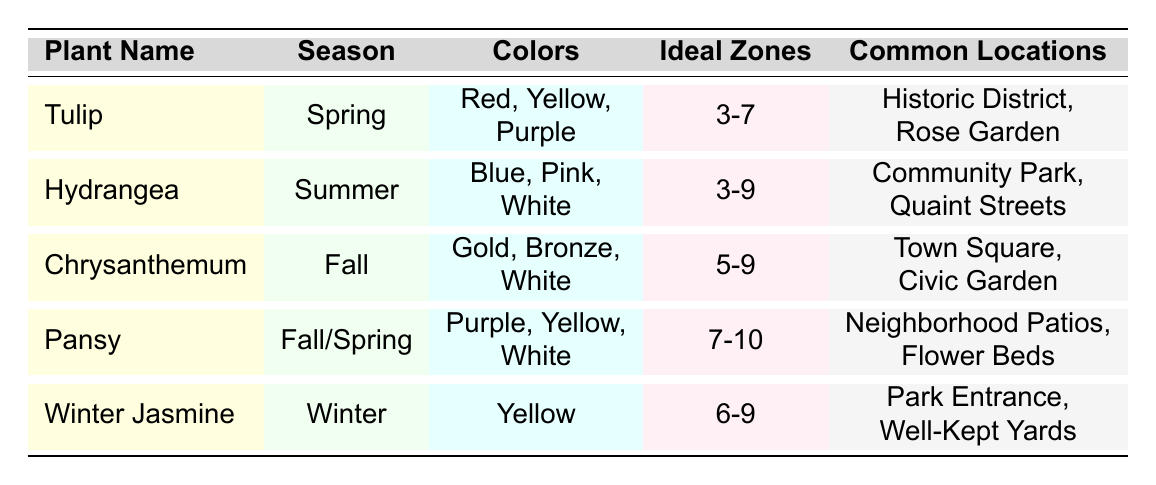What is the common location for Tulips? The table lists the common locations for Tulips as "Historic District" and "Rose Garden."
Answer: Historic District, Rose Garden Which season does the Hydrangea bloom? According to the table, the Hydrangea blooms in the Summer season.
Answer: Summer How many colors does the Chrysanthemum come in? The table indicates that Chrysanthemums come in three colors: Gold, Bronze, and White.
Answer: 3 Is Winter Jasmine suitable for growing in Zone 5? The ideal zones for Winter Jasmine are listed as 6-9, which means it cannot grow in Zone 5.
Answer: No What are the colors of Pansies, and during which seasons do they bloom? Pansies can be purple, yellow, or white and bloom in both Spring and Fall according to the table.
Answer: Purple, Yellow, White; Spring, Fall Which plant variety appears in both spring and fall seasons? The table shows that Pansies are the only plant variety that blooms in both Spring and Fall.
Answer: Pansy What is the ideal zone range for the Tulip? The ideal zones for Tulips are listed as 3-7.
Answer: 3-7 Which plant has the widest ideal zone range, and what is it? By comparing the ideal zones in the table, Hydrangea has the widest range from 3-9.
Answer: Hydrangea; 3-9 How many common locations are associated with the Chrysanthemum? The common locations for the Chrysanthemum are "Town Square" and "Civic Garden," which totals to two locations.
Answer: 2 